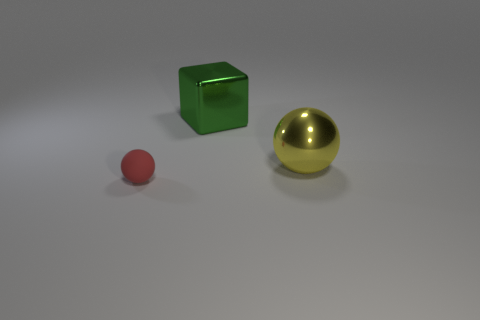Add 1 tiny gray rubber spheres. How many objects exist? 4 Subtract all blocks. How many objects are left? 2 Add 1 large green cubes. How many large green cubes are left? 2 Add 3 green shiny cubes. How many green shiny cubes exist? 4 Subtract 0 cyan cylinders. How many objects are left? 3 Subtract all large purple spheres. Subtract all yellow shiny objects. How many objects are left? 2 